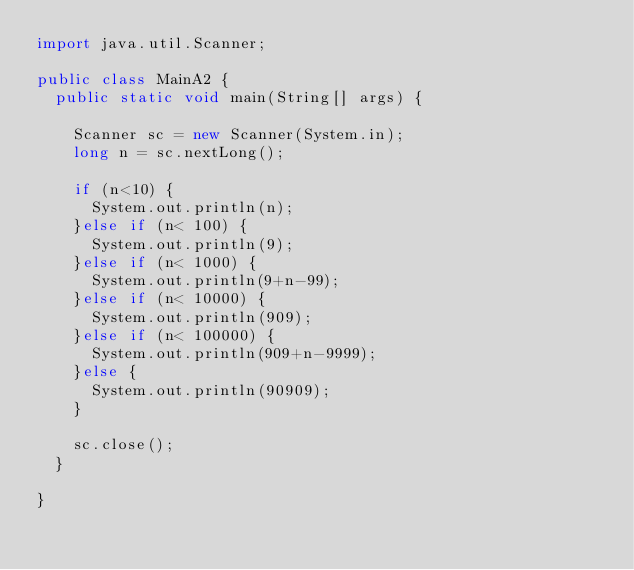Convert code to text. <code><loc_0><loc_0><loc_500><loc_500><_Java_>import java.util.Scanner;

public class MainA2 {
	public static void main(String[] args) {
		
		Scanner sc = new Scanner(System.in);
		long n = sc.nextLong();

		if (n<10) {
			System.out.println(n);
		}else if (n< 100) {
			System.out.println(9);
		}else if (n< 1000) {
			System.out.println(9+n-99);
		}else if (n< 10000) {
			System.out.println(909);
		}else if (n< 100000) {
			System.out.println(909+n-9999);
		}else {
			System.out.println(90909);
		}
		
		sc.close();
	}

}</code> 